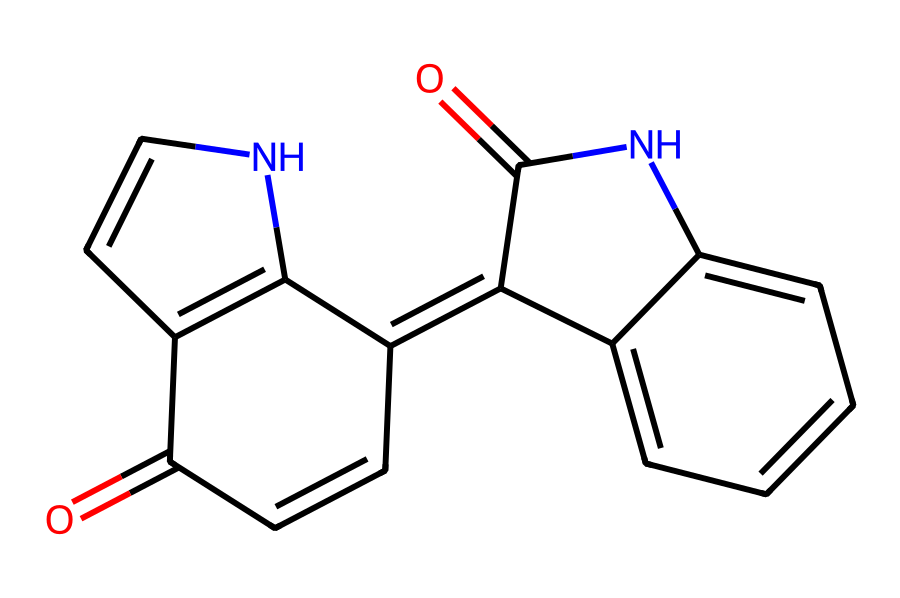How many nitrogen atoms are in this chemical structure? By examining the SMILES representation, we can identify the presence of nitrogen atoms, which are indicated by the letter 'N'. In the given structure, there are two 'N' present.
Answer: 2 What type of functional groups are present in this compound? The functional groups that can be identified in the structure include carbonyl groups (C=O) which are represented by the 'C=O' notation in the SMILES. Also, there are nitrogen-containing groups which suggest the presence of amine or similar functionality.
Answer: carbonyl and nitrogen-containing groups How many double bonds are there in the structure? The structure features multiple double bonds. By counting the '=' symbols and understanding that they represent double bonds, we find a total of 6 double bonds in the molecule.
Answer: 6 What is the total number of carbon atoms in this chemical? By interpreting the SMILES representation, we can count the carbon (C) atoms. Each 'C' in the SMILES indicates a carbon atom. There are a total of 15 'C' in the structure.
Answer: 15 Is this compound likely to be soluble in organic solvents or water? The presence of nitrogen atoms and carbonyl groups suggest that this compound has some polar characteristics, which typically enhance solubility in polar organic solvents rather than water. Therefore, it is likely more soluble in organic solvents.
Answer: organic solvents What class of compounds does this molecular structure belong to? Given the presence of multiple fused rings and nitrogen atoms, this molecular structure can be classified as an alkaloid, which is a class of naturally occurring organic compounds that mostly contain basic nitrogen atoms.
Answer: alkaloid 